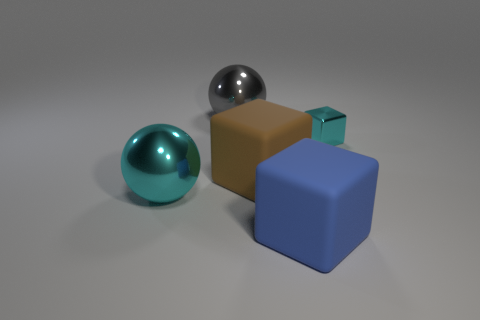Subtract all tiny shiny cubes. How many cubes are left? 2 Add 3 brown objects. How many objects exist? 8 Add 5 tiny cyan things. How many tiny cyan things exist? 6 Subtract 0 yellow cubes. How many objects are left? 5 Subtract all spheres. How many objects are left? 3 Subtract all gray blocks. Subtract all purple cylinders. How many blocks are left? 3 Subtract all cyan spheres. Subtract all matte cubes. How many objects are left? 2 Add 4 big blue blocks. How many big blue blocks are left? 5 